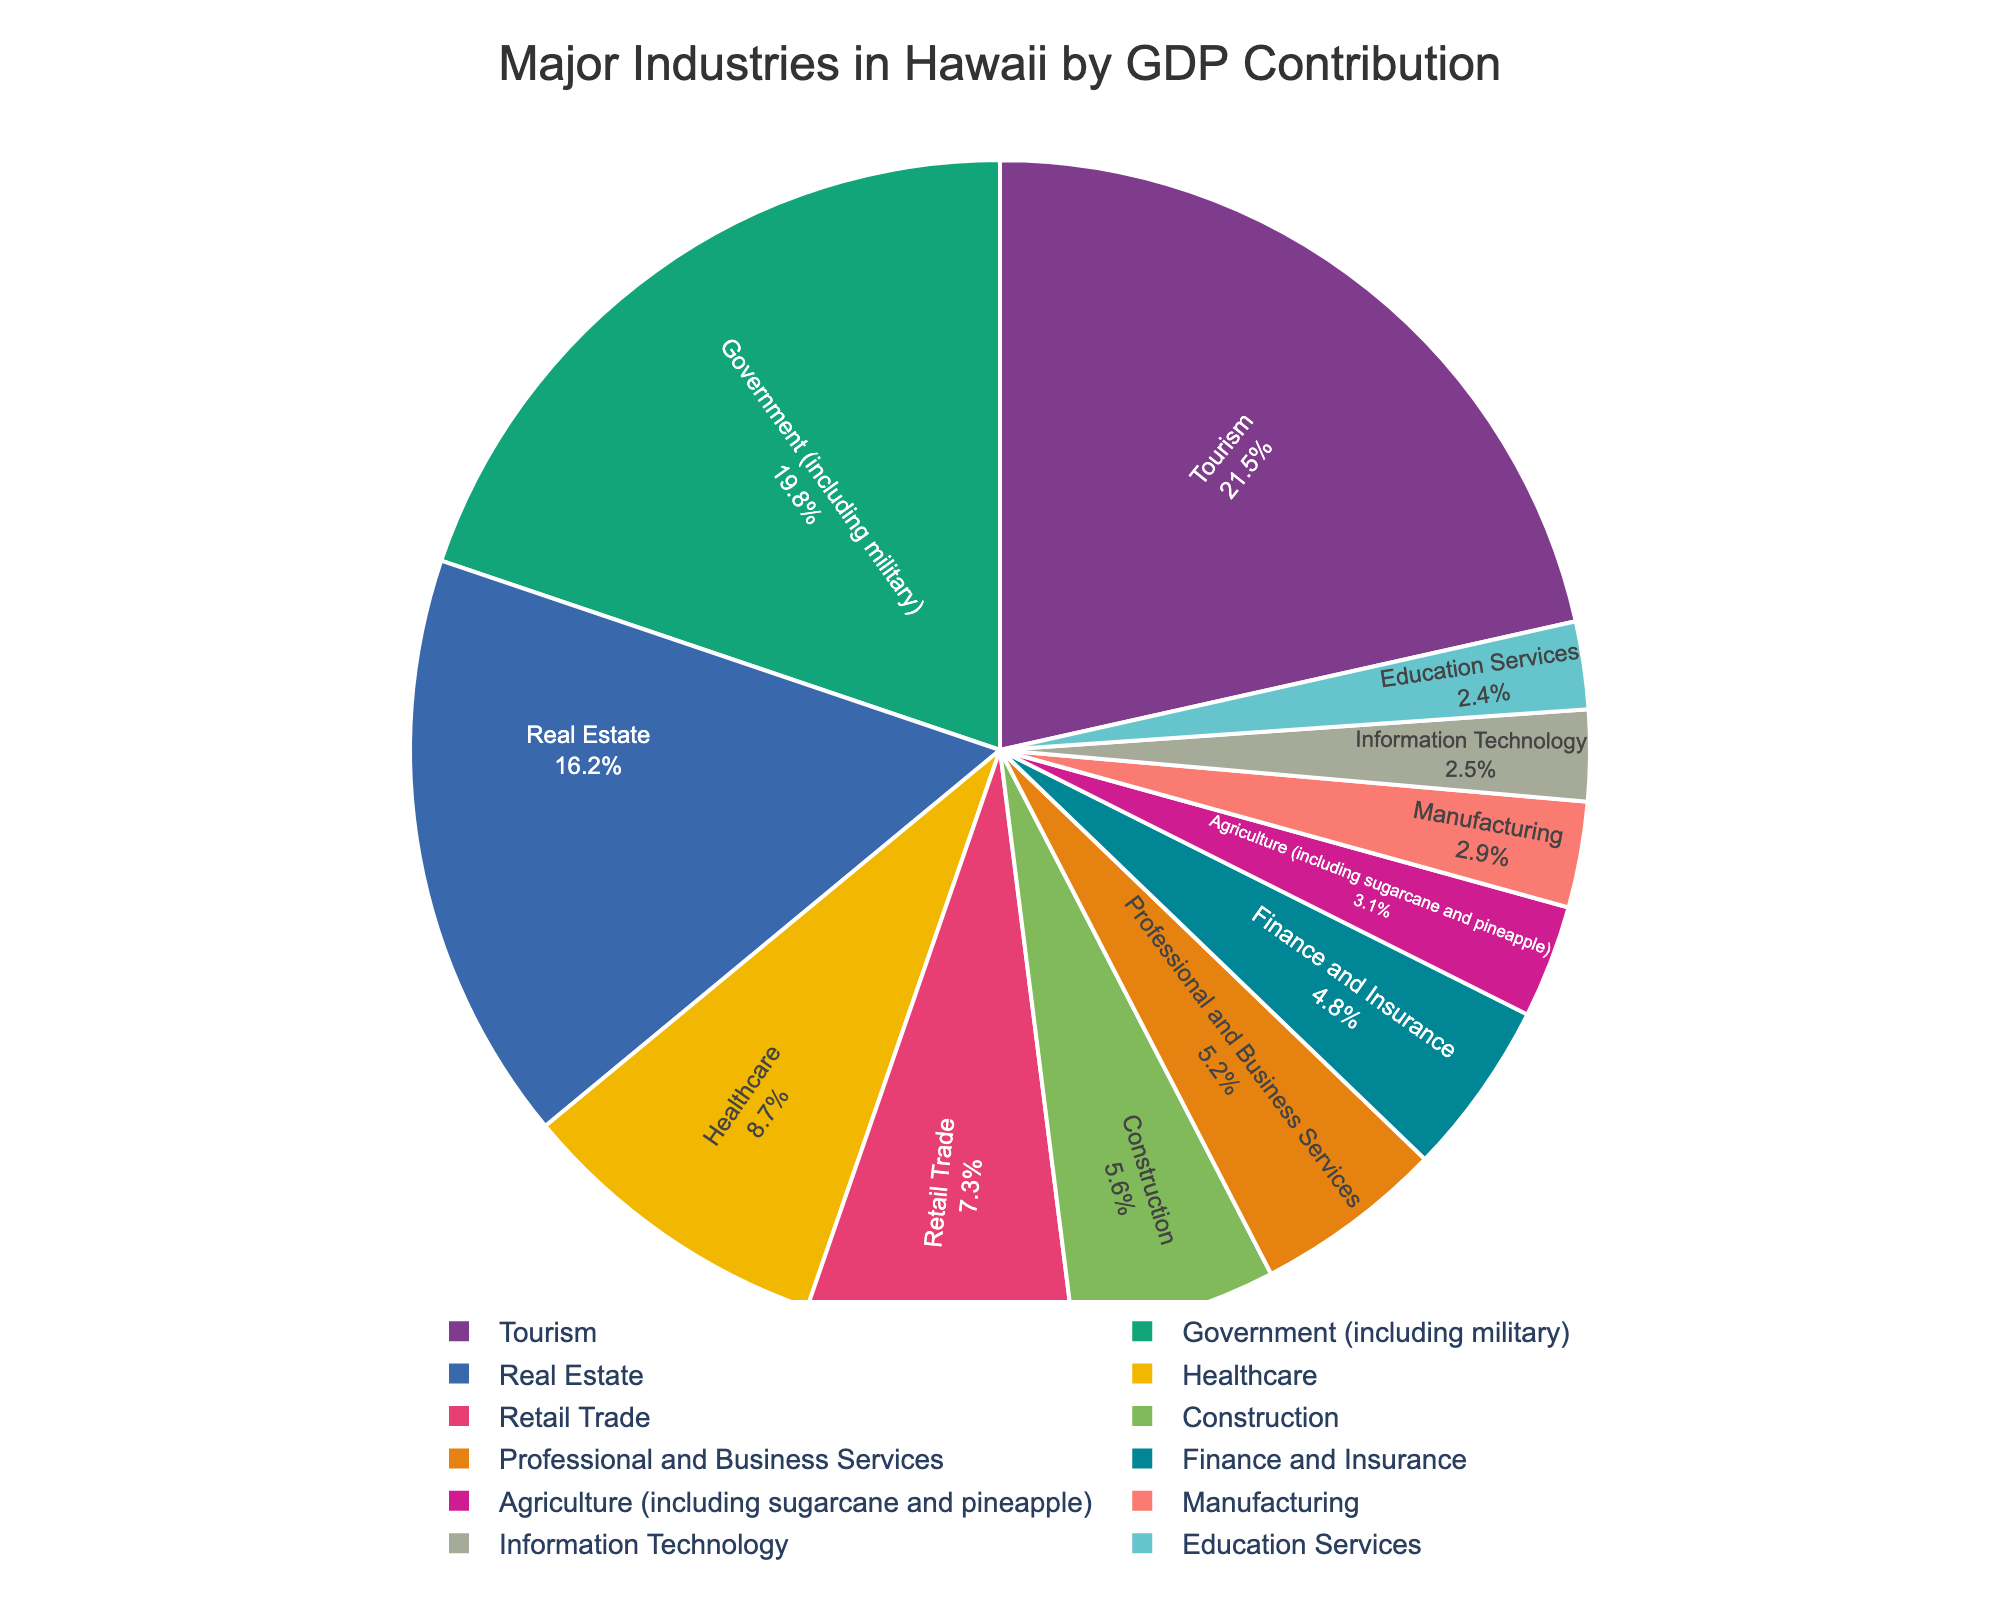What is the industry with the highest GDP contribution in Hawaii? To determine the industry with the highest GDP contribution, identify the industry with the largest percentage value in the figure. The largest percentage value is 21.5%, which belongs to Tourism.
Answer: Tourism Which two industries have the closest GDP contribution percentages? To find the two industries with the closest GDP contribution percentages, compare the percentage values in the figure. The closest values are Agriculture (3.1%) and Manufacturing (2.9%), with only a 0.2% difference.
Answer: Agriculture and Manufacturing What is the combined GDP contribution percentage of Tourism, Government, and Real Estate? Add the GDP contribution percentages of Tourism, Government, and Real Estate: 21.5% (Tourism) + 19.8% (Government) + 16.2% (Real Estate) = 57.5%.
Answer: 57.5% Which industry contributes more to Hawaii's GDP: Healthcare or Retail Trade? Identify the percentages for Healthcare (8.7%) and Retail Trade (7.3%) and compare them. Healthcare has the higher percentage.
Answer: Healthcare Is the GDP contribution of Education Services greater than that of Information Technology? Compare the GDP contribution percentages of Education Services (2.4%) and Information Technology (2.5%). Since Information Technology is 2.5% and Education Services is 2.4%, Information Technology is higher.
Answer: No By how much does the GDP contribution of Construction exceed that of Agriculture? Subtract Agriculture's percentage (3.1%) from Construction's percentage (5.6%): 5.6% - 3.1% = 2.5%.
Answer: 2.5% What's the total GDP contribution percentage of industries with less than 5% contribution each? Add the percentages for Professional and Business Services (5.2%), Finance and Insurance (4.8%), Agriculture (3.1%), Manufacturing (2.9%), Information Technology (2.5%), and Education Services (2.4%). Note Professional and Business Services just equals 5%, rest total to: 4.8% + 3.1% + 2.9% + 2.5% + 2.4% = 15.7%.
Answer: 15.7% Which industry has a larger GDP contribution: Real Estate or Healthcare and Retail Trade combined? First, combine the GDP percentages for Healthcare (8.7%) and Retail Trade (7.3%): 8.7% + 7.3% = 16%. Then compare this sum to Real Estate's contribution of 16.2%. Real Estate has a larger contribution.
Answer: Real Estate What is the average GDP contribution of Government, Real Estate, and Construction? Sum the GDP percentages of Government (19.8%), Real Estate (16.2%), and Construction (5.6%), then divide by the number of industries: (19.8% + 16.2% + 5.6%) / 3 = 41.6% / 3 ≈ 13.87%.
Answer: ~13.87% 